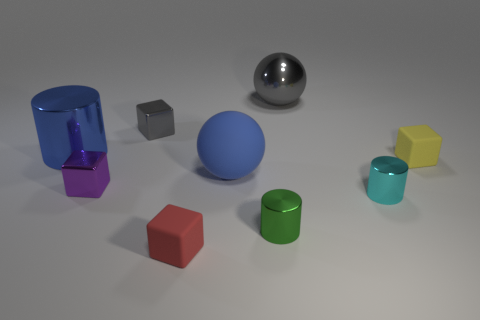Can you describe the lighting in the scene and how it affects the appearance of the objects? The lighting in the scene appears to be overhead and relatively soft, casting gentle shadows directly beneath each object. This diffuse light highlights the colors and textures of the objects, enhancing their three-dimensional appearance without creating harsh contrasts or reflections. 